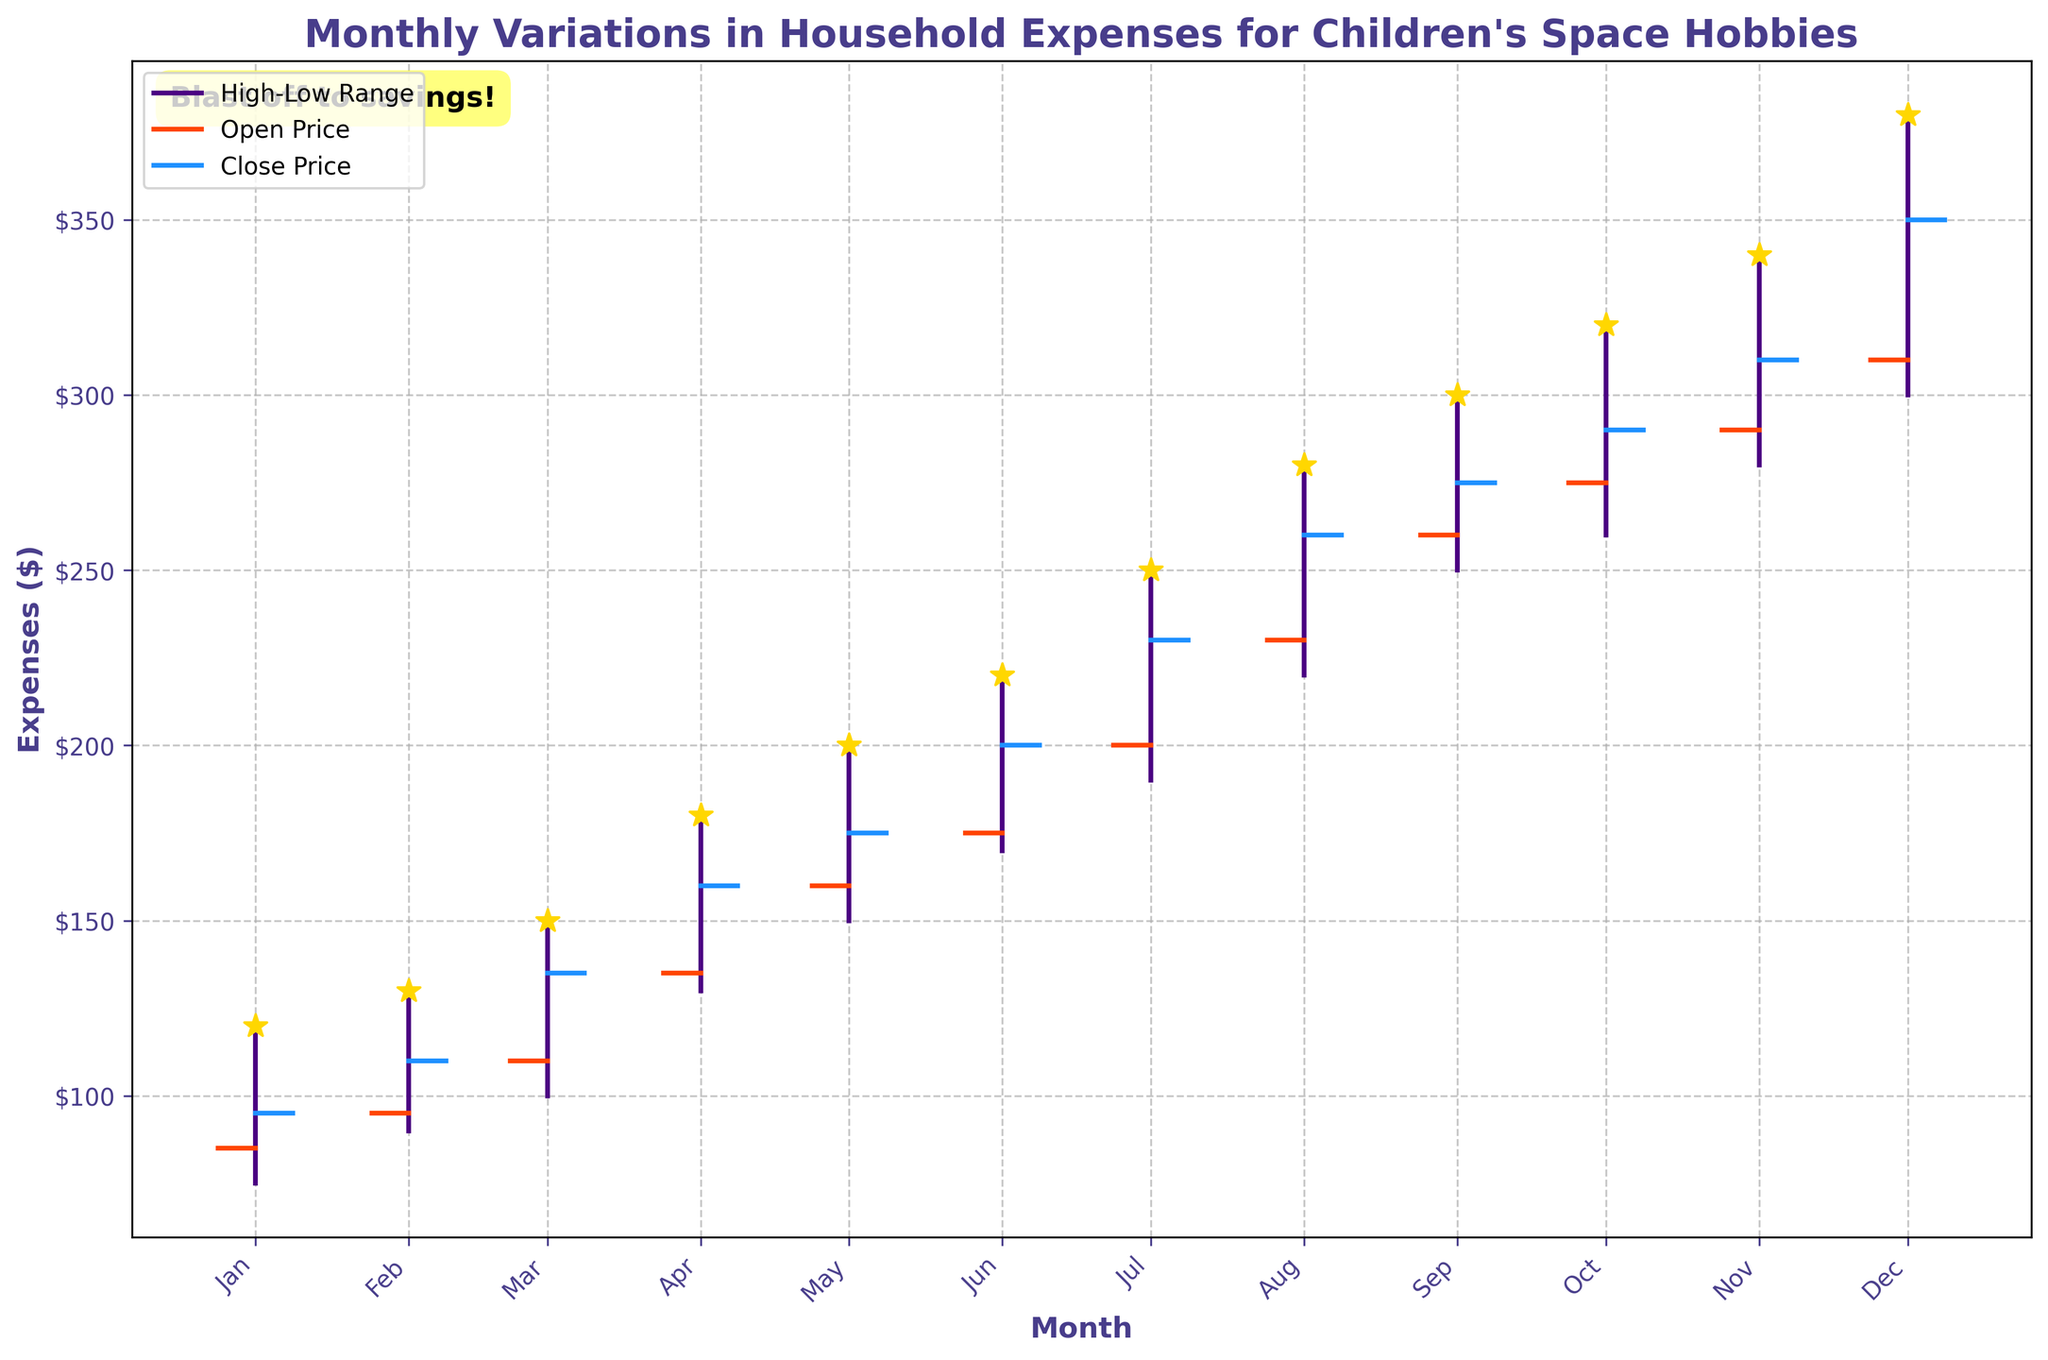What is the highest household expense recorded in any month for children's hobbies? To identify the highest household expense, look for the maximum value on the "High" axis. The figure shows that the highest value recorded is in December at $380.
Answer: $380 Which month has the lowest expenditure at the end of the month (Close price)? To find the lowest expenditure for the end of month, look for the smallest "Close" value across all months. January has the lowest Close price recorded at $95.
Answer: January By how much did the household expenses rise by the end of June compared to the initial value at the start of January? Compare the Close value at the end of June to the Open value at the start of January. The January Open is $85 and June Close is $200. The increase is calculated as $200 - $85.
Answer: $115 Which month had the smallest range between the highest and lowest expenses? To find the smallest range, subtract the "Low" value from the "High" value for each month and find the smallest difference. For example, January's range is $120 - $75 = $45. Doing this for all months reveals that June has the smallest range of $50 (High $220 - Low $170).
Answer: June Did the household expenses generally increase, decrease, or stay the same over the year? Examine the trend from the Open price in January to the Close price in December. The Open price in January is $85 and the Close price in December is $350, reflecting a general increase in expenses over the year.
Answer: Increase Which month represents the largest increase in expenditure when comparing the Open and Close prices within the same month? Subtract the Open price from the Close price for all months and find the largest difference. February's increase is $110 - $95 = $15, while December has an increase of $350 - $310 = $40, and so on. The largest increase is in December, $350 - $310 = $40.
Answer: December What is the overall trend of household expenses from April to August? Look at the sequence of Close prices from April to August. The values are April $160, May $175, June $200, July $230, and August $260, showing a consistent upward trend.
Answer: Upward Trend How does the average High value for the first half of the year (January to June) compare to the average High value for the second half (July to December)? Calculate the average High value from January to June and from July to December. First half: (120+130+150+180+200+220)/6 = 1000/6 ≈ 166.67. Second half: (250+280+300+320+340+380)/6 = 1870/6 ≈ 311.67.
Answer: Second half is higher Which month had the highest opening expense and how much was it? Identify the month with the highest value in the Open column. The chart shows December with the highest Open value of $310.
Answer: December, $310 How many months had a closing expense value greater than $200? Count the months where the Close value is above $200. From the chart, July, August, September, October, November, and December all have values above $200.
Answer: 6 